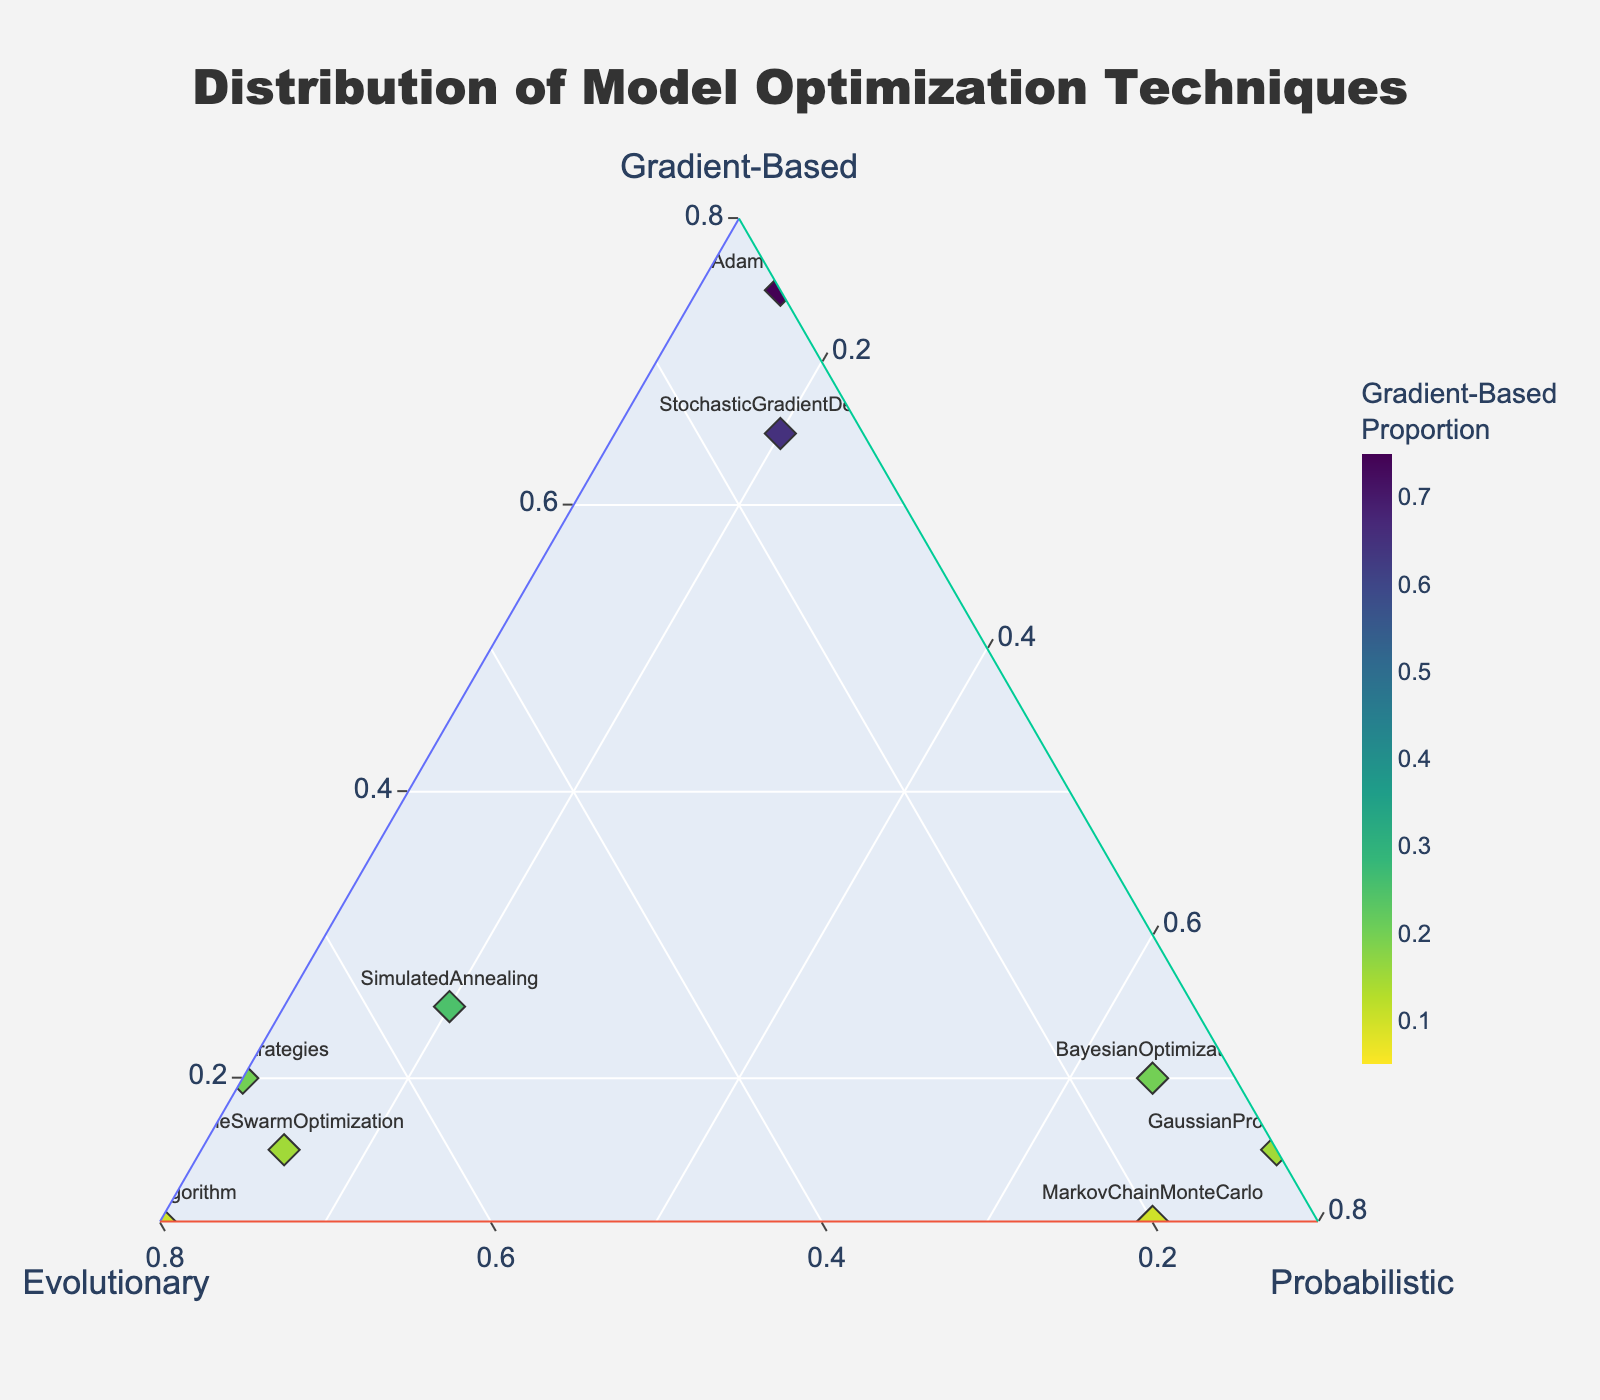Which technique has the highest proportion of gradient-based optimization? The diamond marker closest to the top corner of the plot signifies the highest proportion of gradient-based optimization. The marker labeled "AdamOptimizer" is closest to this corner, indicating the highest gradient-based proportion.
Answer: AdamOptimizer Which technique relies most on probabilistic methods? The diamond marker closest to the right corner of the plot signifies the highest proportion of probabilistic methods. The marker labeled "GaussianProcessRegression" is closest to this corner, indicating the highest probabilistic proportion.
Answer: GaussianProcessRegression Which technique is most balanced in using all three optimization methods? The most balanced technique would be closest to the center of the ternary plot. By looking for a marker near the central area, "SimulatedAnnealing" appears closest to the center, indicating a more balanced use of all three methods.
Answer: SimulatedAnnealing How does the gradient-based proportion of "StochasticGradientDescent" compare to "AdamOptimizer"? "AdamOptimizer" has a marker plotting at 0.75 on the Gradient-Based axis, while "StochasticGradientDescent" is plotted at 0.65. Thus, "AdamOptimizer" has a higher gradient-based proportion.
Answer: AdamOptimizer has a higher proportion Which technique is most dominated by evolutionary methods? The diamond marker closest to the left corner of the plot corresponds to the highest proportion of evolutionary methods. The marker labeled "DifferentialEvolution" is closest to this corner, indicating the highest evolutionary proportion.
Answer: DifferentialEvolution What is the gradient-based proportion of "GeneticAlgorithm"? By looking at the marker labeled "GeneticAlgorithm" on the plot, it is positioned at 0.10 on the Gradient-Based axis.
Answer: 0.10 Among "ParticleSwarmOptimization", "EvolutionStrategies", and "GeneticAlgorithm", which uses probabilistic methods the most? Compare the positions of these three markers along the Probabilistic axis. "ParticleSwarmOptimization" is at 0.15, "EvolutionStrategies" is at 0.10, and "GeneticAlgorithm" is also at 0.10. Therefore, "ParticleSwarmOptimization" uses probabilistic methods the most among them.
Answer: ParticleSwarmOptimization What is the difference in evolutionary proportion between "BayesianOptimization" and "MarkovChainMonteCarlo"? "BayesianOptimization" has a proportion of 0.15 on the Evolutionary axis, and "MarkovChainMonteCarlo" has a proportion of 0.20 on the same axis. The difference is
Answer: 0.05 